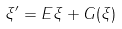Convert formula to latex. <formula><loc_0><loc_0><loc_500><loc_500>\xi ^ { \prime } = E \xi + G ( \xi )</formula> 